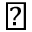<formula> <loc_0><loc_0><loc_500><loc_500>\natural</formula> 